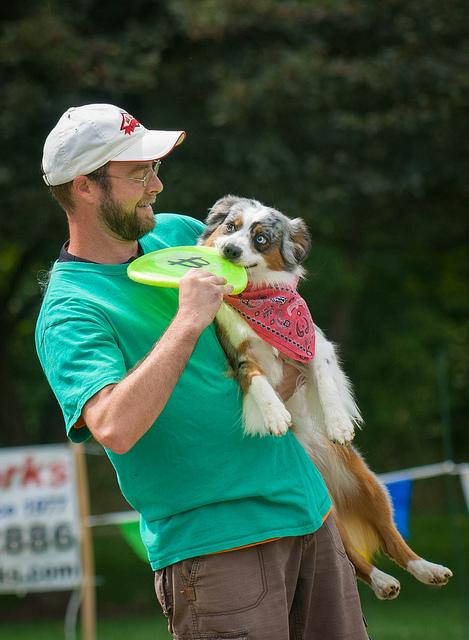What is the color of the man's shirt?
Be succinct. Green. Is the dog biting on a frisbee with a B on it?
Answer briefly. Yes. Is the man wearing a hat?
Concise answer only. Yes. 